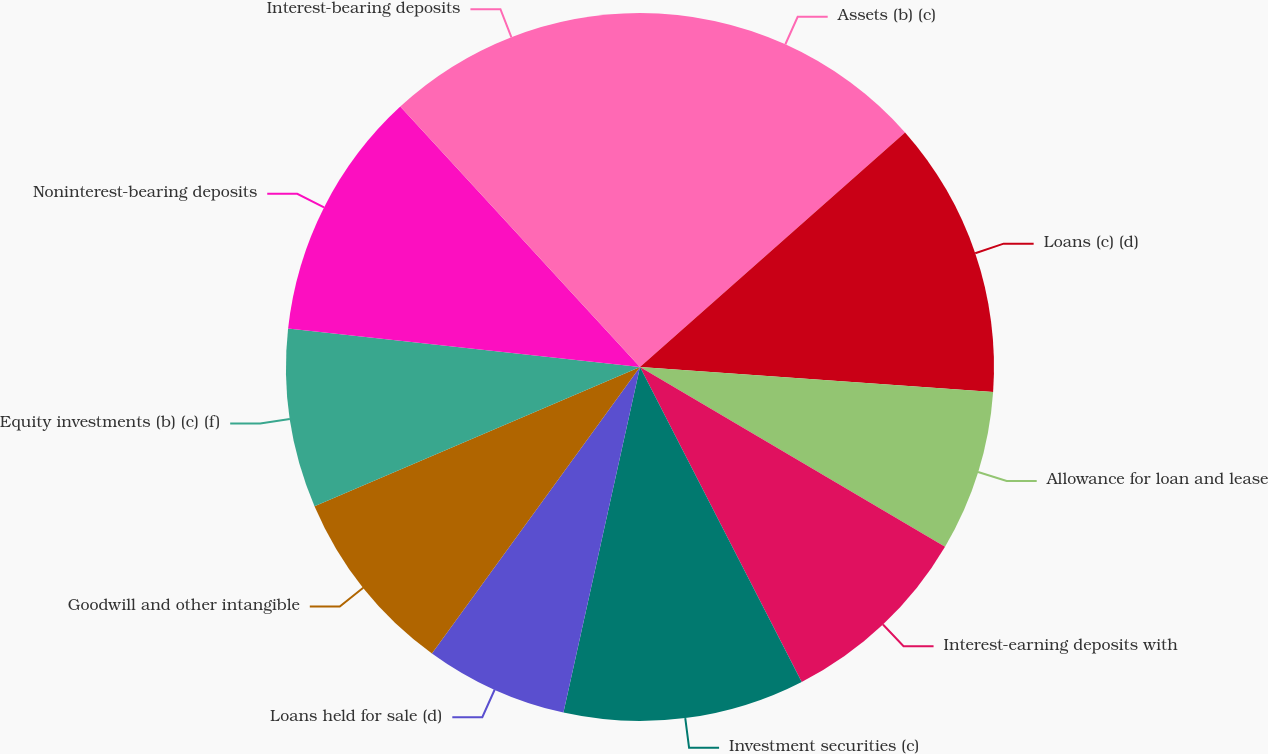<chart> <loc_0><loc_0><loc_500><loc_500><pie_chart><fcel>Assets (b) (c)<fcel>Loans (c) (d)<fcel>Allowance for loan and lease<fcel>Interest-earning deposits with<fcel>Investment securities (c)<fcel>Loans held for sale (d)<fcel>Goodwill and other intangible<fcel>Equity investments (b) (c) (f)<fcel>Noninterest-bearing deposits<fcel>Interest-bearing deposits<nl><fcel>13.47%<fcel>12.65%<fcel>7.35%<fcel>8.98%<fcel>11.02%<fcel>6.53%<fcel>8.57%<fcel>8.16%<fcel>11.43%<fcel>11.84%<nl></chart> 